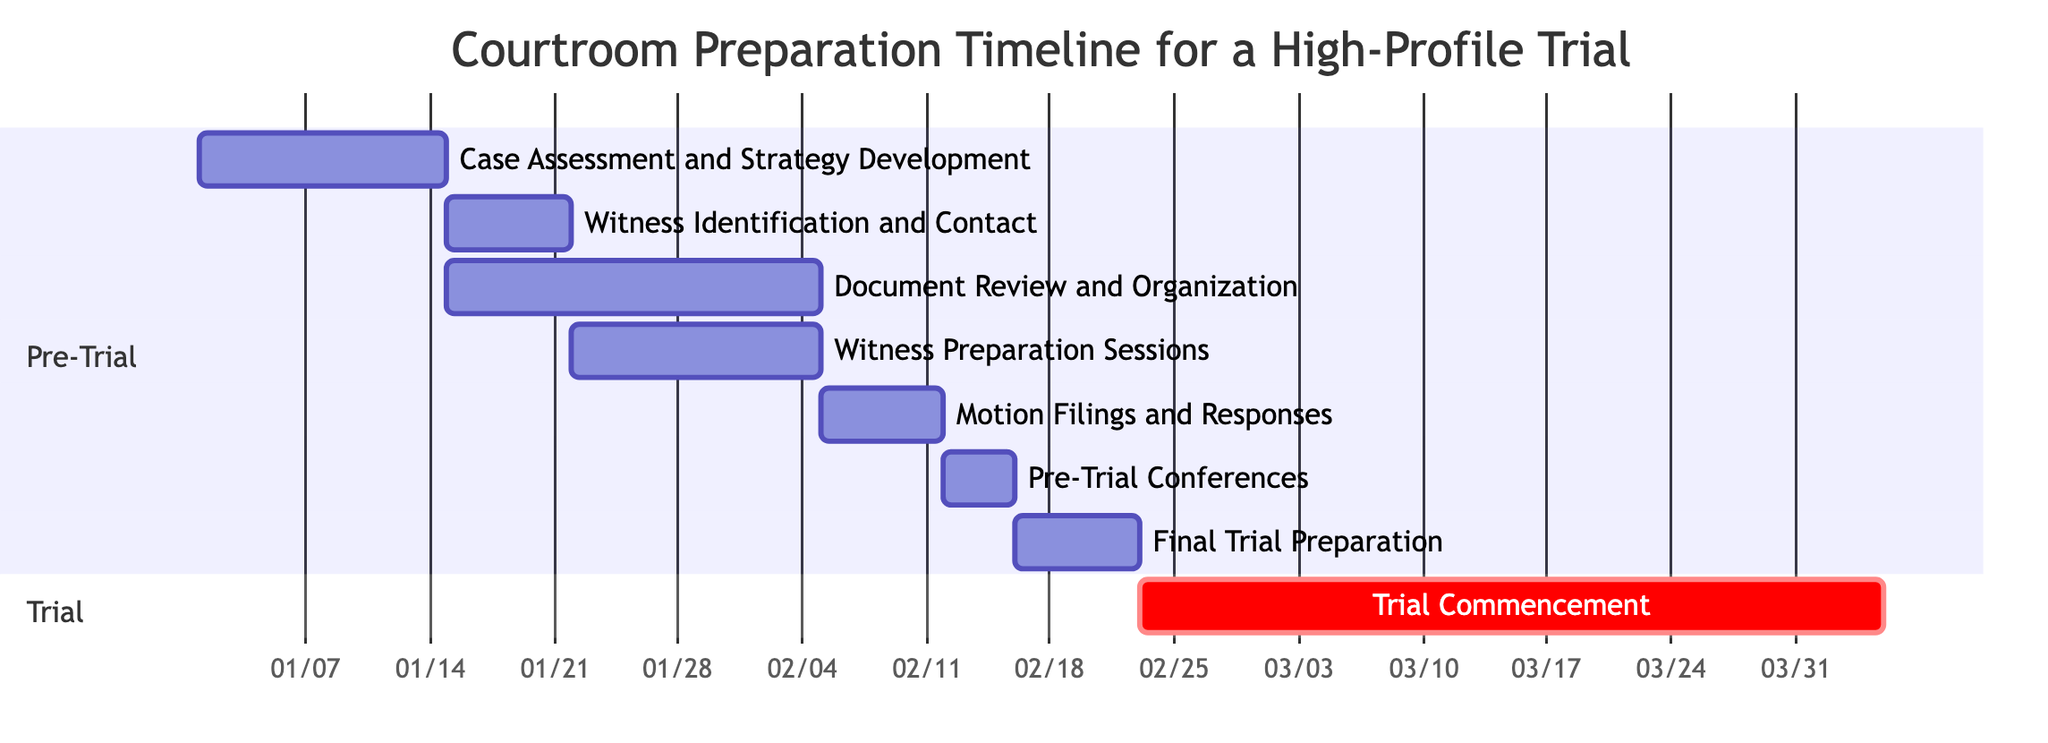What is the duration of the Trial Commencement activity? The Trial Commencement activity is represented on the Gantt chart and is labeled with a duration of 6 weeks. This information can be directly inferred from the timeline of the trial.
Answer: 6 weeks Which activity starts immediately after the Witness Identification and Contact? The activity "Document Review and Organization" begins on the same day as the "Witness Identification and Contact" ends, which is on January 15, 2024. Therefore, it starts immediately after it completes.
Answer: Document Review and Organization How many total weeks are allocated for Witness Preparation Sessions? The "Witness Preparation Sessions" activity is clearly indicated to have a duration of 2 weeks. This is explicitly labeled on the Gantt chart timeline.
Answer: 2 weeks What is the total number of pre-trial activities? To find the total pre-trial activities, we count the activities listed in the pre-trial section: there are 6 activities: Case Assessment and Strategy Development, Witness Identification and Contact, Document Review and Organization, Witness Preparation Sessions, Motion Filings and Responses, and Pre-Trial Conferences.
Answer: 6 When does the Final Trial Preparation end? The "Final Trial Preparation" activity starts on February 16, 2024, and lasts for 1 week, which means it ends on February 22, 2024. This can be calculated by adding the week duration to the start date.
Answer: 2024-02-22 What is the relationship between Document Review and Organization and Witness Preparation Sessions activities? The "Document Review and Organization" activity and the "Witness Preparation Sessions" activity overlap in their timeline. Both activities start on January 15, 2024, but the "Document Review" lasts until February 4, while "Witness Preparation Sessions" ends on the same date. This indicates they occur in parallel.
Answer: Overlap How long is the time gap between the end of Pre-Trial Conferences and the start of Final Trial Preparation? The "Pre-Trial Conferences" end on February 15, 2024, and the "Final Trial Preparation" starts on February 16, 2024. There is no gap; they are consecutive activities that begin immediately after one another.
Answer: No gap Which activity has the longest duration before the trial commences? The "Trial Commencement" activity has the longest duration, lasting for 6 weeks. However, prior activities leading up to it, like "Document Review and Organization" and "Witness Preparation Sessions," have substantial durations but do not match the trial's duration.
Answer: Trial Commencement 